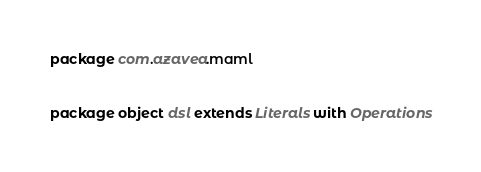<code> <loc_0><loc_0><loc_500><loc_500><_Scala_>package com.azavea.maml


package object dsl extends Literals with Operations
</code> 